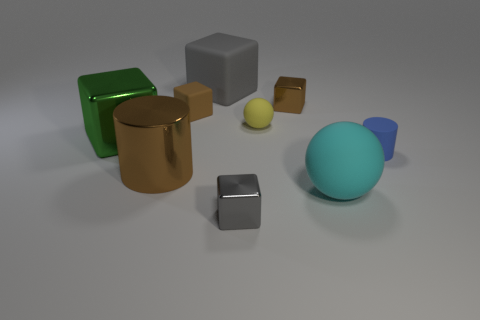Subtract 2 cubes. How many cubes are left? 3 Subtract all big green cubes. How many cubes are left? 4 Subtract all green cubes. How many cubes are left? 4 Subtract all cyan cubes. Subtract all blue cylinders. How many cubes are left? 5 Subtract all cylinders. How many objects are left? 7 Subtract all big metallic cylinders. Subtract all big green rubber cylinders. How many objects are left? 8 Add 3 small brown blocks. How many small brown blocks are left? 5 Add 3 big brown things. How many big brown things exist? 4 Subtract 0 red cubes. How many objects are left? 9 